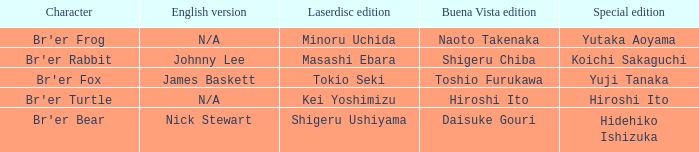What is the special edition where the english version is nick stewart? Hidehiko Ishizuka. 